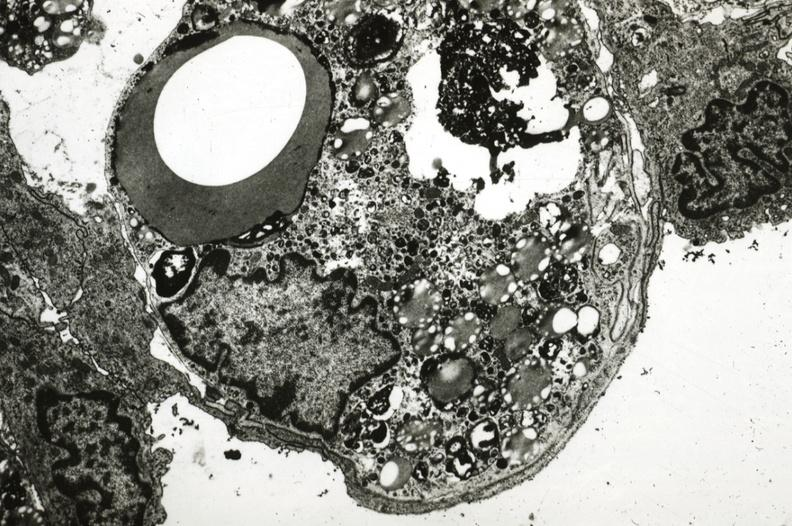does this image show rabbit lesion with foam cell immediately beneath endothelium?
Answer the question using a single word or phrase. Yes 